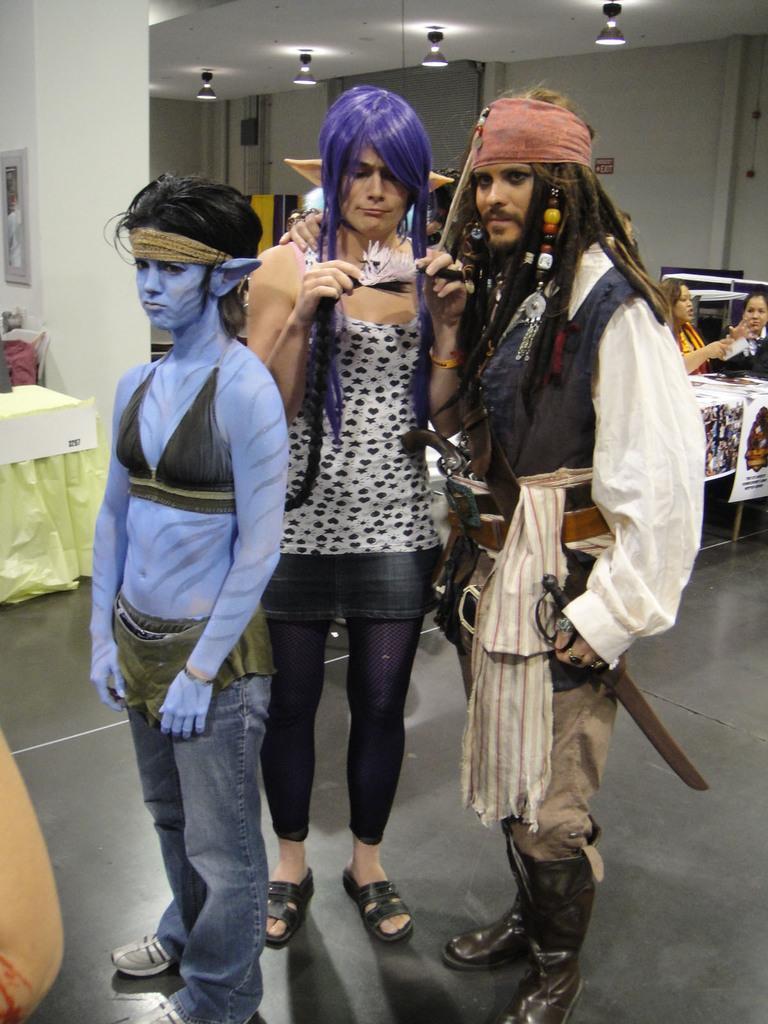Could you give a brief overview of what you see in this image? In this image, we can see three people are standing on the floor. Here we can see a person is holding some object. Background we can see tables with cloth, banners. Right side of the image, we can see two people are sitting. Here there is a wall, sign boards, pipe, frame. Top of the image, there is a roof with lights. 